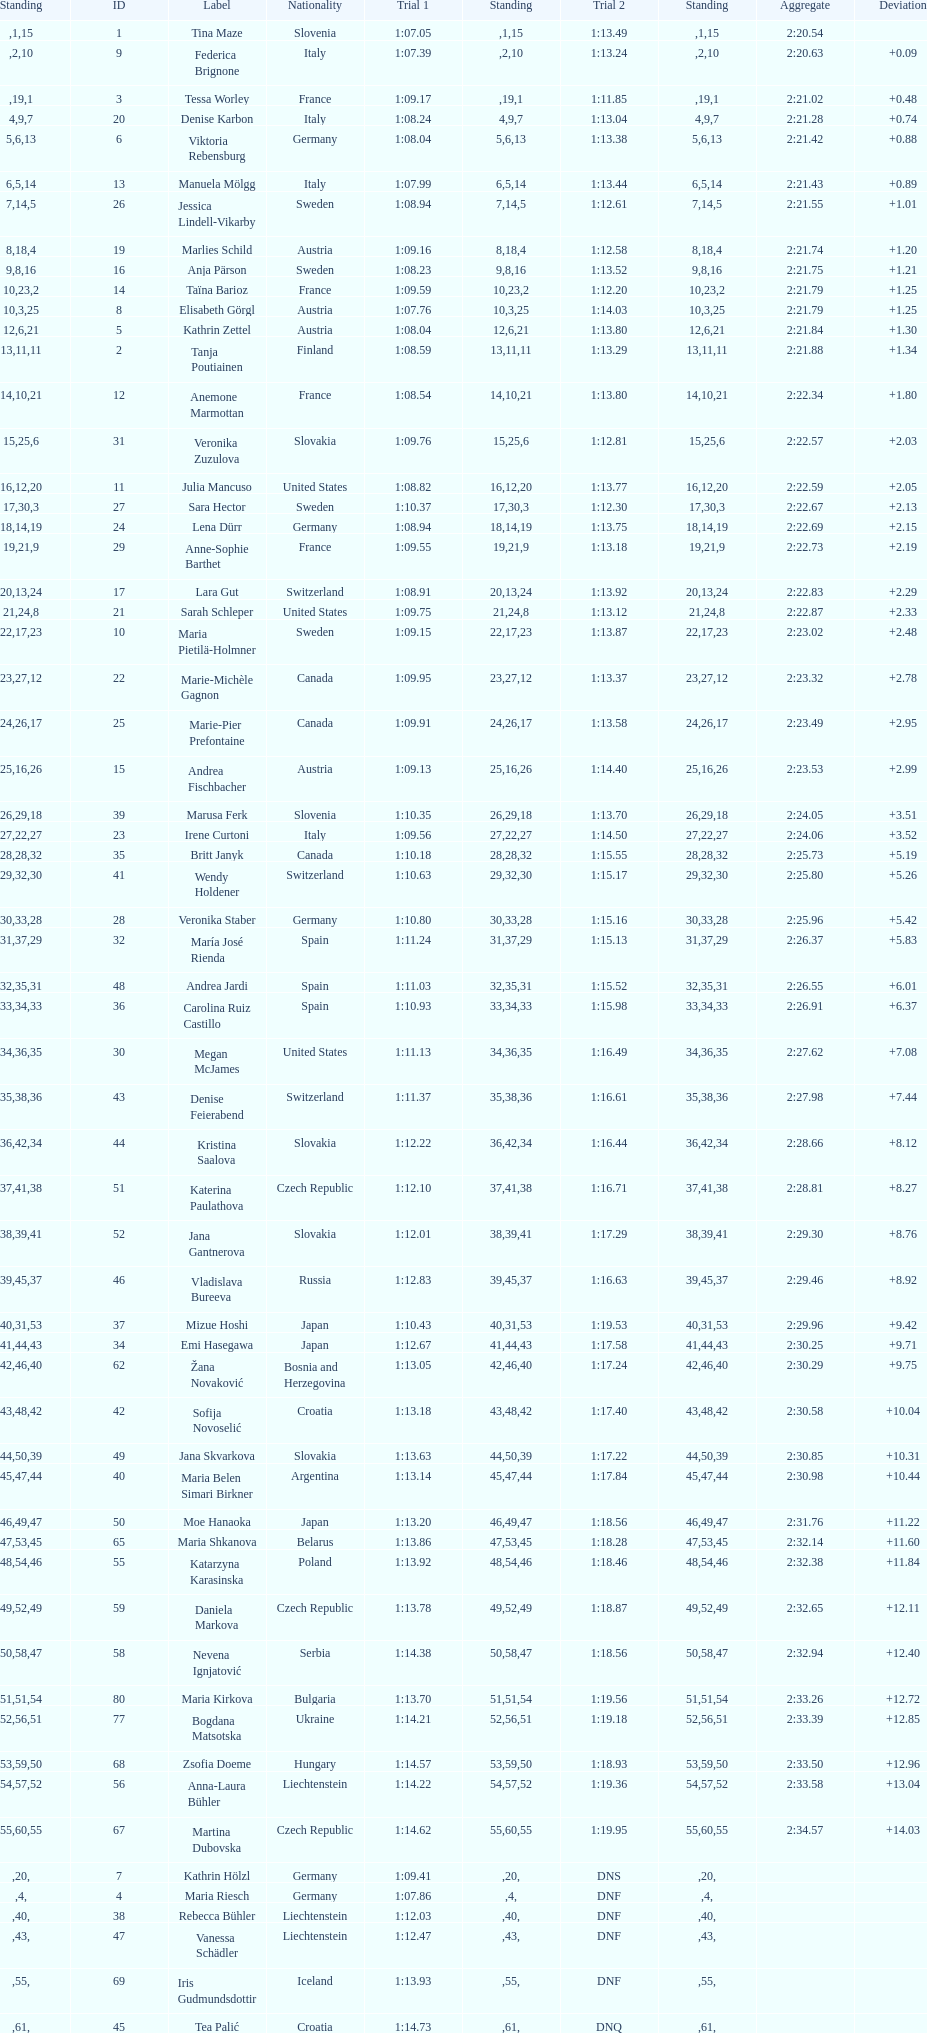Who finished next after federica brignone? Tessa Worley. 